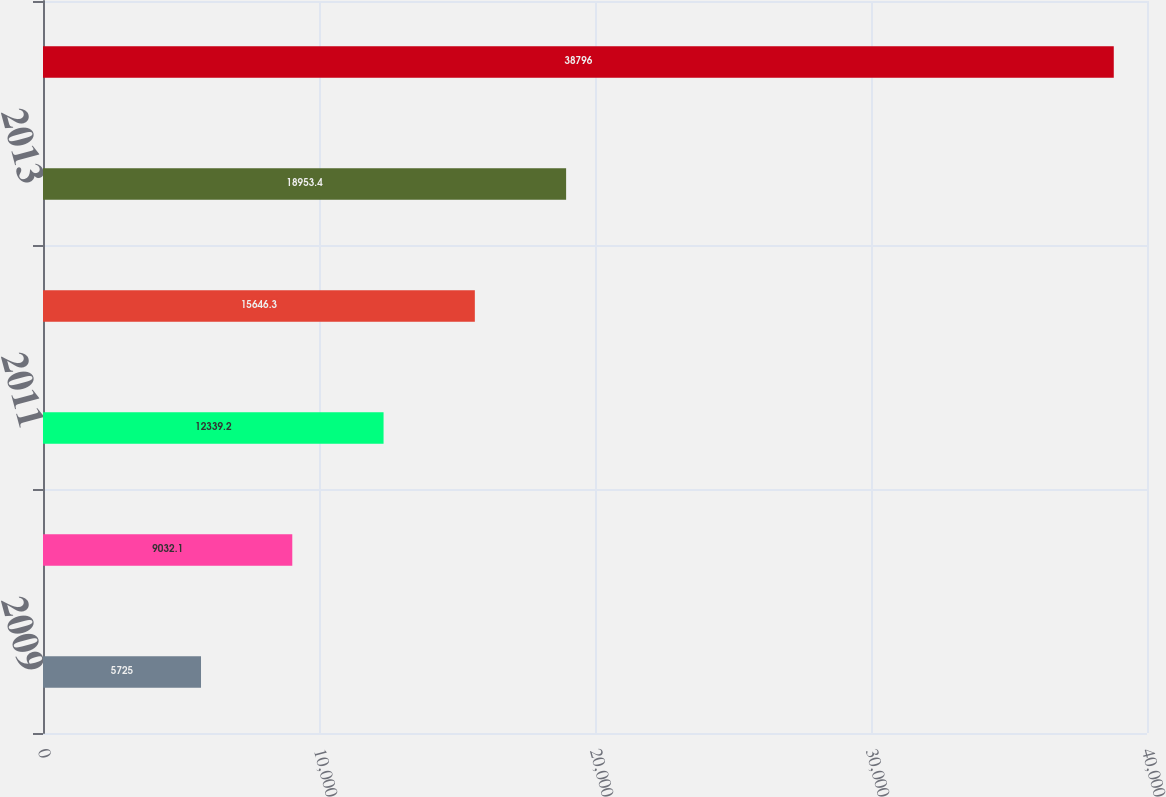<chart> <loc_0><loc_0><loc_500><loc_500><bar_chart><fcel>2009<fcel>2010<fcel>2011<fcel>2012<fcel>2013<fcel>2014-2018<nl><fcel>5725<fcel>9032.1<fcel>12339.2<fcel>15646.3<fcel>18953.4<fcel>38796<nl></chart> 